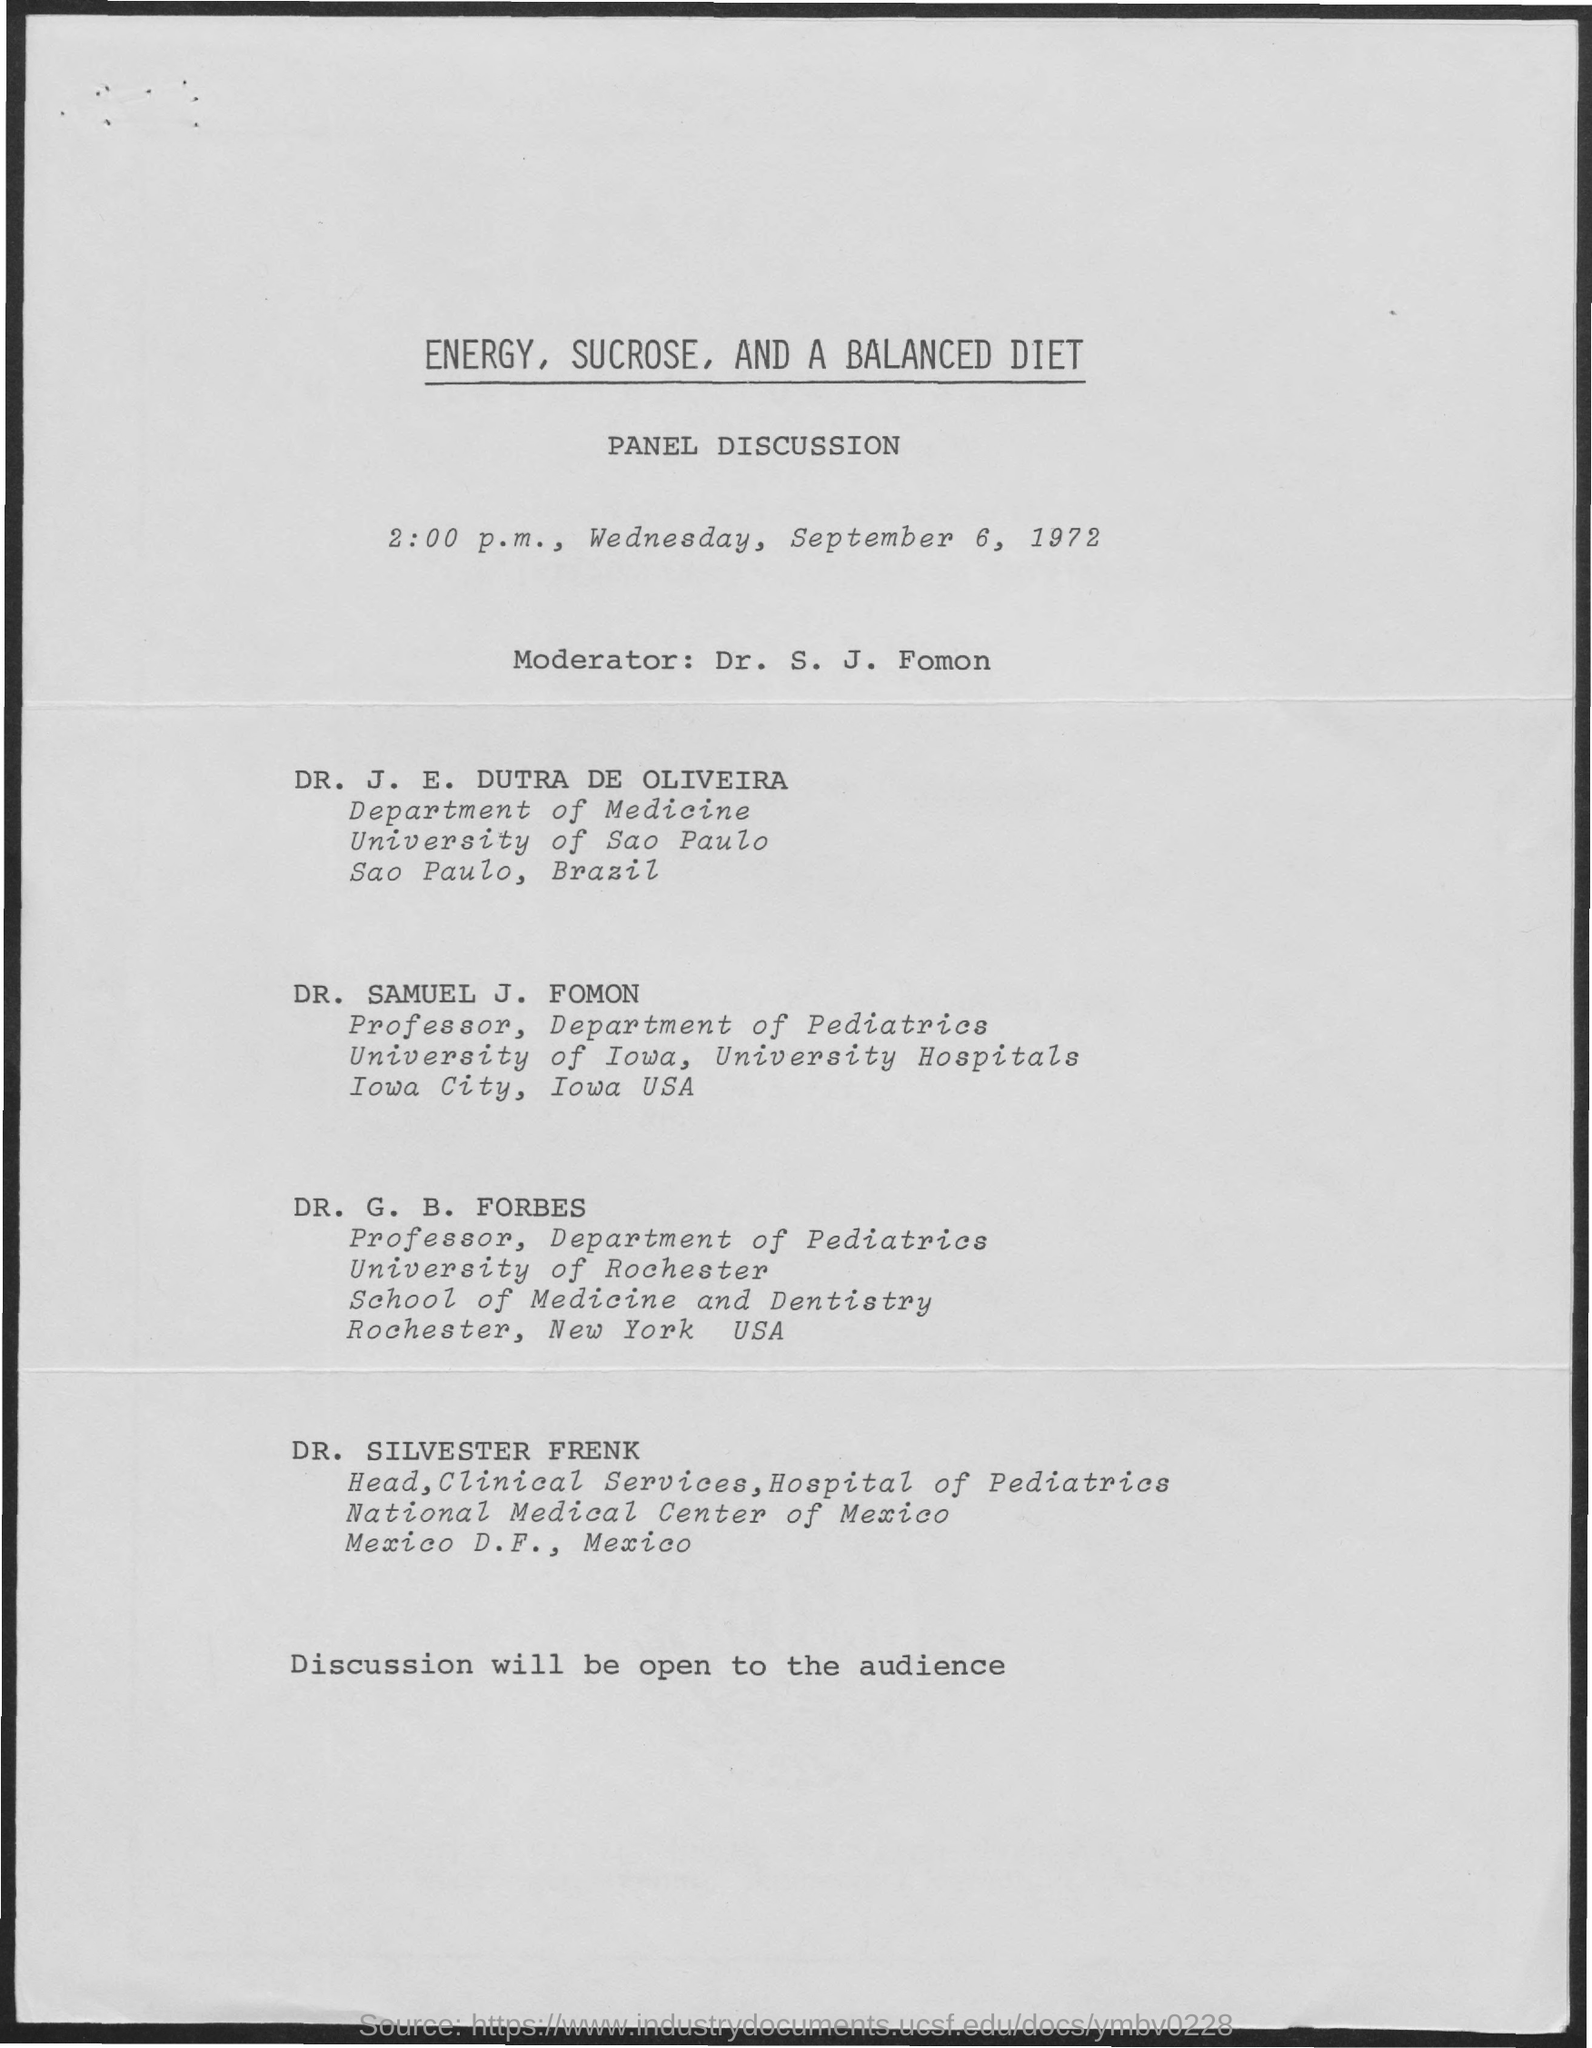Give some essential details in this illustration. This document's first title is 'Energy, Sucrose, and A Balanced Diet.' Dr. S.J. Fomon is the moderator. 